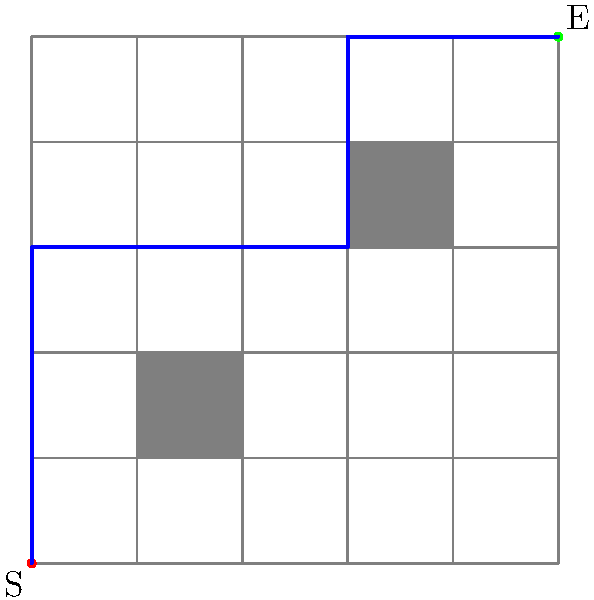In the given 5x5 grid maze with obstacles (gray squares), what is the minimum number of moves required to reach the end point (E) from the start point (S) if diagonal movements are not allowed? To solve this pathfinding problem, we'll use a step-by-step approach:

1. Understand the constraints:
   - The maze is a 5x5 grid
   - Gray squares are obstacles and cannot be traversed
   - Diagonal movements are not allowed
   - We can only move up, down, left, or right

2. Identify the start (S) and end (E) points:
   - Start: (0, 0)
   - End: (5, 5)

3. Find the optimal path:
   - Move up from (0, 0) to (0, 3) to avoid the first obstacle: 3 moves
   - Move right from (0, 3) to (3, 3) to reach the row of the second obstacle: 3 moves
   - Move up from (3, 3) to (3, 5) to avoid the second obstacle: 2 moves
   - Move right from (3, 5) to (5, 5) to reach the end point: 2 moves

4. Count the total number of moves:
   $$ 3 + 3 + 2 + 2 = 10 $$

Therefore, the minimum number of moves required to reach the end point from the start point is 10.
Answer: 10 moves 